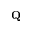<formula> <loc_0><loc_0><loc_500><loc_500>Q</formula> 